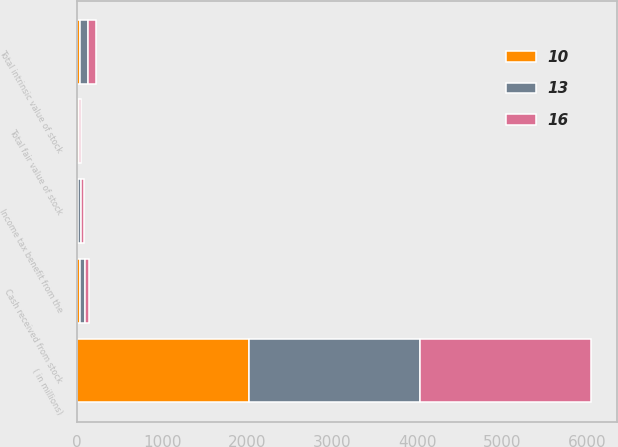Convert chart to OTSL. <chart><loc_0><loc_0><loc_500><loc_500><stacked_bar_chart><ecel><fcel>( in millions)<fcel>Total intrinsic value of stock<fcel>Cash received from stock<fcel>Income tax benefit from the<fcel>Total fair value of stock<nl><fcel>10<fcel>2016<fcel>34<fcel>32<fcel>12<fcel>16<nl><fcel>16<fcel>2015<fcel>92<fcel>53<fcel>31<fcel>13<nl><fcel>13<fcel>2014<fcel>92<fcel>57<fcel>33<fcel>10<nl></chart> 